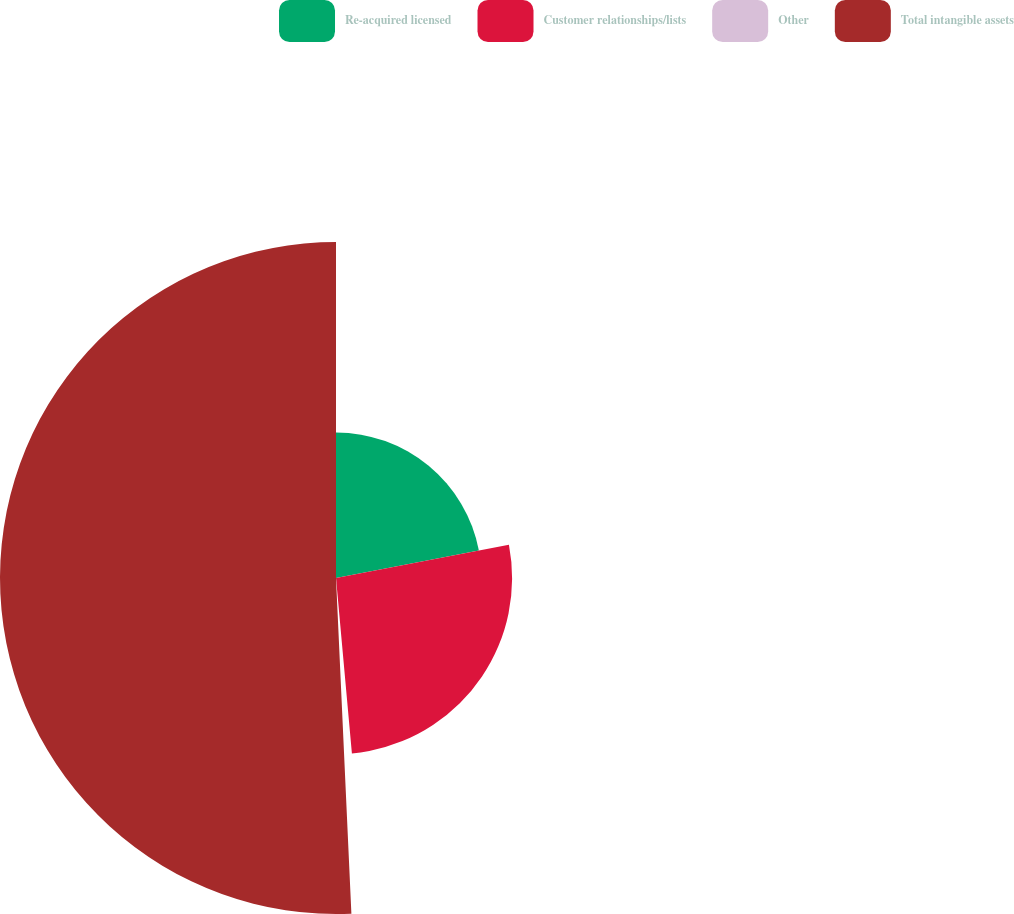Convert chart to OTSL. <chart><loc_0><loc_0><loc_500><loc_500><pie_chart><fcel>Re-acquired licensed<fcel>Customer relationships/lists<fcel>Other<fcel>Total intangible assets<nl><fcel>21.97%<fcel>26.59%<fcel>0.71%<fcel>50.73%<nl></chart> 